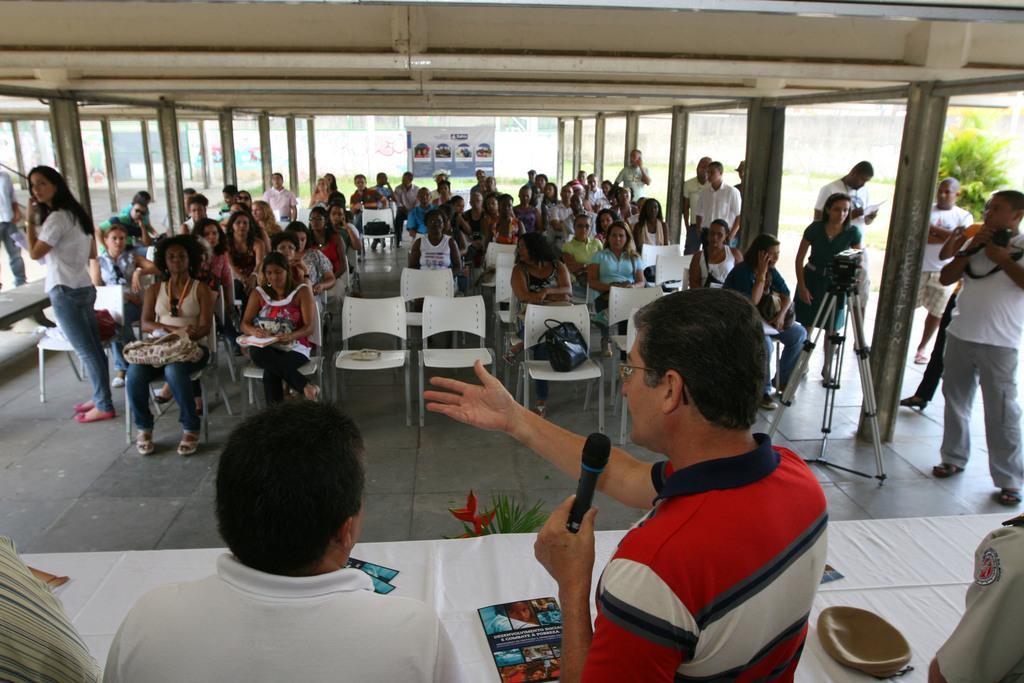Can you describe this image briefly? In this picture there are people and table at the bottom side of the image and there are other people those who are sitting on the chairs in the center of the image. 